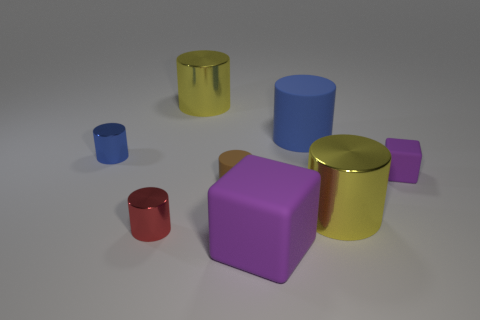Subtract all yellow cylinders. How many cylinders are left? 4 Subtract all big yellow cylinders. How many cylinders are left? 4 Subtract all gray cylinders. Subtract all green blocks. How many cylinders are left? 6 Add 2 tiny green rubber objects. How many objects exist? 10 Subtract all blocks. How many objects are left? 6 Add 5 big yellow metallic cylinders. How many big yellow metallic cylinders are left? 7 Add 1 tiny red metallic objects. How many tiny red metallic objects exist? 2 Subtract 1 blue cylinders. How many objects are left? 7 Subtract all large blue objects. Subtract all small cyan matte spheres. How many objects are left? 7 